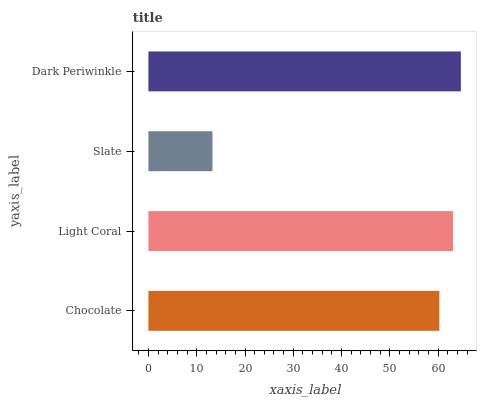Is Slate the minimum?
Answer yes or no. Yes. Is Dark Periwinkle the maximum?
Answer yes or no. Yes. Is Light Coral the minimum?
Answer yes or no. No. Is Light Coral the maximum?
Answer yes or no. No. Is Light Coral greater than Chocolate?
Answer yes or no. Yes. Is Chocolate less than Light Coral?
Answer yes or no. Yes. Is Chocolate greater than Light Coral?
Answer yes or no. No. Is Light Coral less than Chocolate?
Answer yes or no. No. Is Light Coral the high median?
Answer yes or no. Yes. Is Chocolate the low median?
Answer yes or no. Yes. Is Chocolate the high median?
Answer yes or no. No. Is Light Coral the low median?
Answer yes or no. No. 